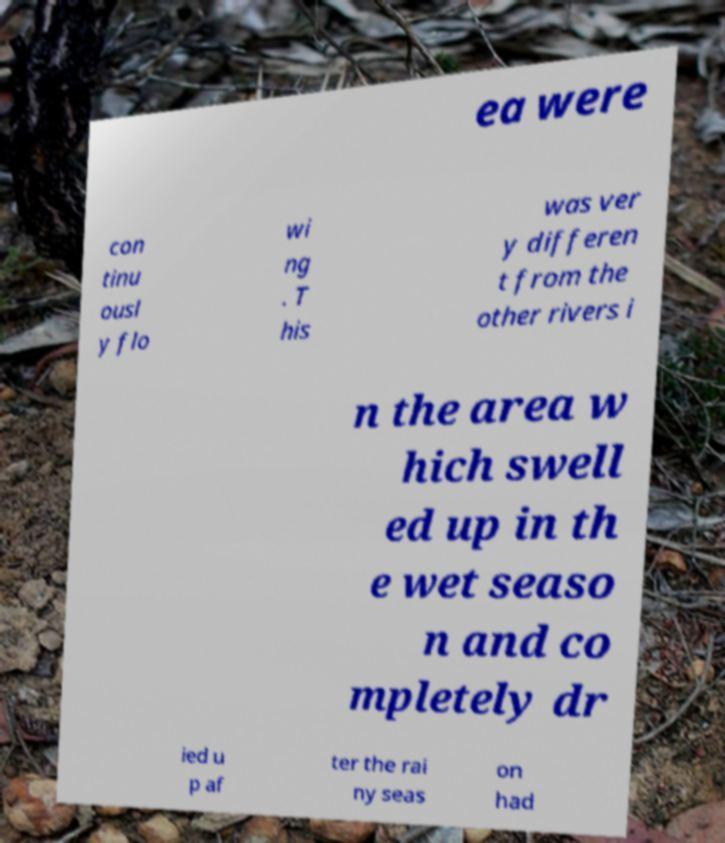What messages or text are displayed in this image? I need them in a readable, typed format. ea were con tinu ousl y flo wi ng . T his was ver y differen t from the other rivers i n the area w hich swell ed up in th e wet seaso n and co mpletely dr ied u p af ter the rai ny seas on had 